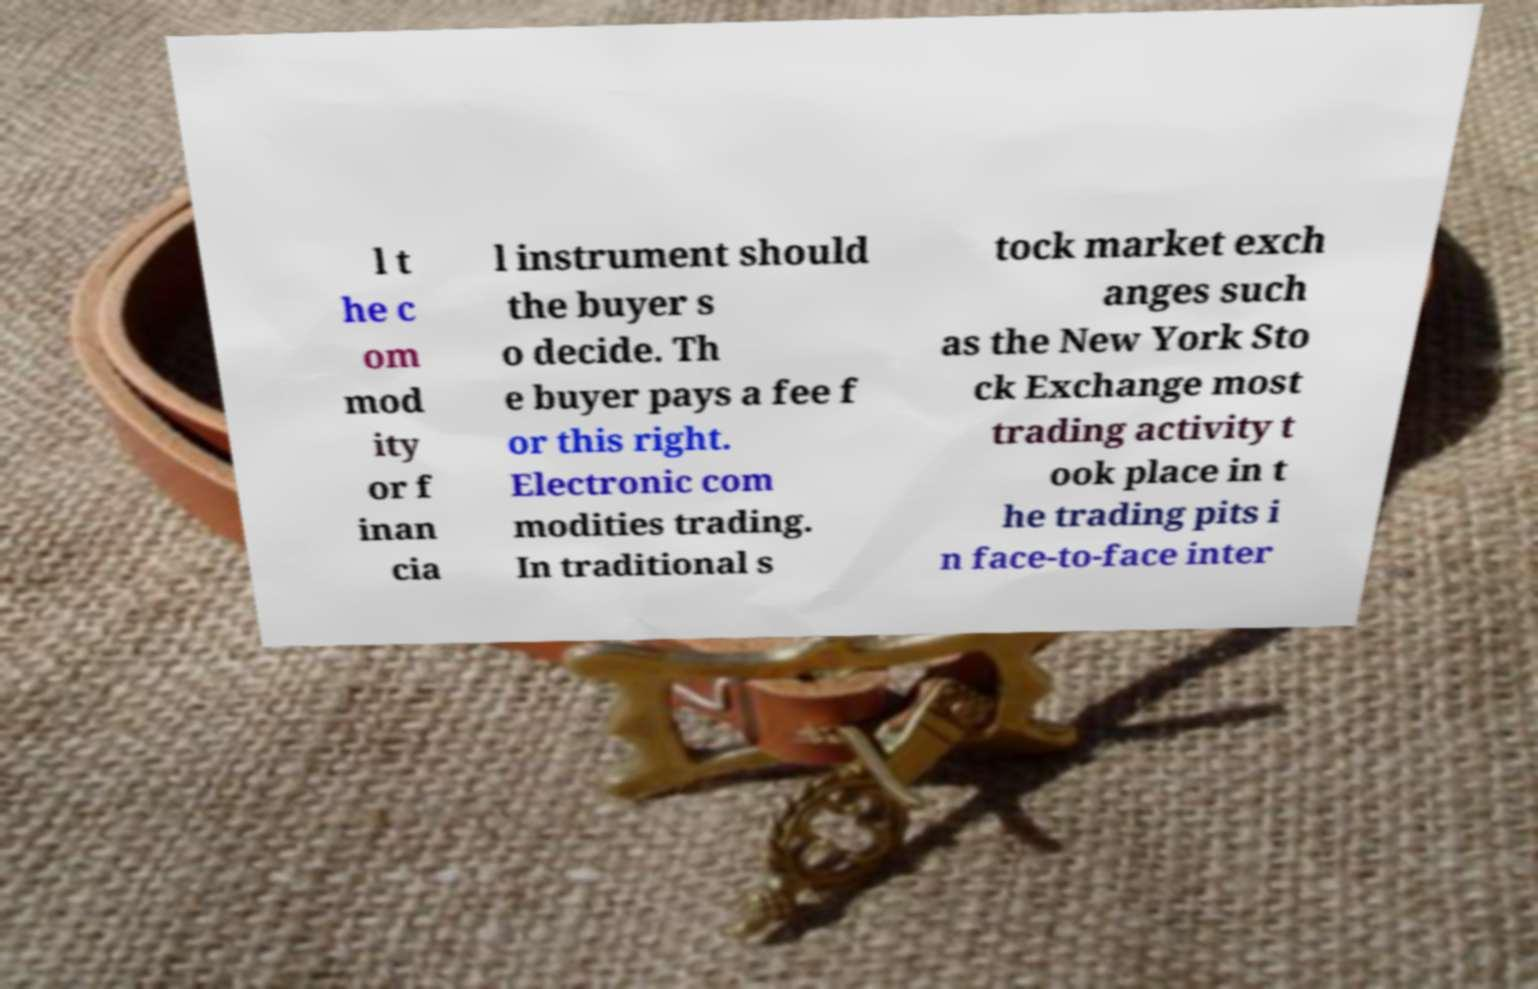Please identify and transcribe the text found in this image. l t he c om mod ity or f inan cia l instrument should the buyer s o decide. Th e buyer pays a fee f or this right. Electronic com modities trading. In traditional s tock market exch anges such as the New York Sto ck Exchange most trading activity t ook place in t he trading pits i n face-to-face inter 